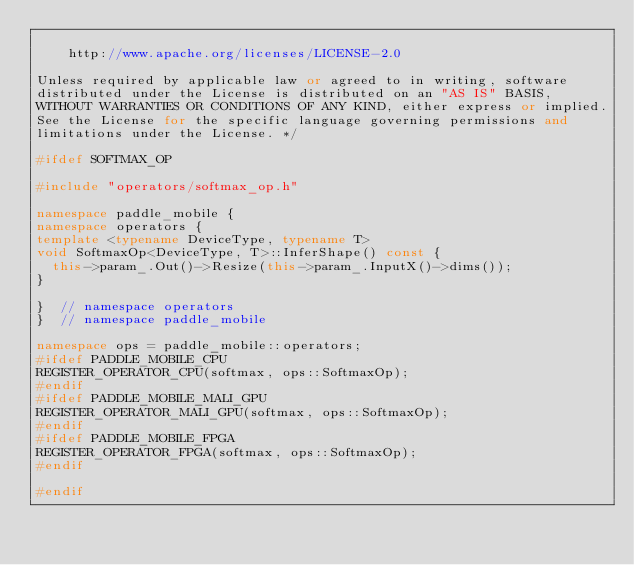Convert code to text. <code><loc_0><loc_0><loc_500><loc_500><_C++_>
    http://www.apache.org/licenses/LICENSE-2.0

Unless required by applicable law or agreed to in writing, software
distributed under the License is distributed on an "AS IS" BASIS,
WITHOUT WARRANTIES OR CONDITIONS OF ANY KIND, either express or implied.
See the License for the specific language governing permissions and
limitations under the License. */

#ifdef SOFTMAX_OP

#include "operators/softmax_op.h"

namespace paddle_mobile {
namespace operators {
template <typename DeviceType, typename T>
void SoftmaxOp<DeviceType, T>::InferShape() const {
  this->param_.Out()->Resize(this->param_.InputX()->dims());
}

}  // namespace operators
}  // namespace paddle_mobile

namespace ops = paddle_mobile::operators;
#ifdef PADDLE_MOBILE_CPU
REGISTER_OPERATOR_CPU(softmax, ops::SoftmaxOp);
#endif
#ifdef PADDLE_MOBILE_MALI_GPU
REGISTER_OPERATOR_MALI_GPU(softmax, ops::SoftmaxOp);
#endif
#ifdef PADDLE_MOBILE_FPGA
REGISTER_OPERATOR_FPGA(softmax, ops::SoftmaxOp);
#endif

#endif
</code> 